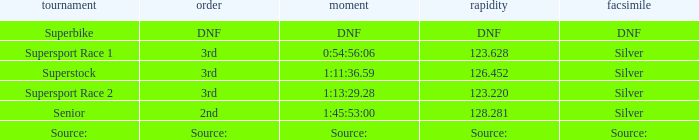Which position has a speed of 123.220? 3rd. 